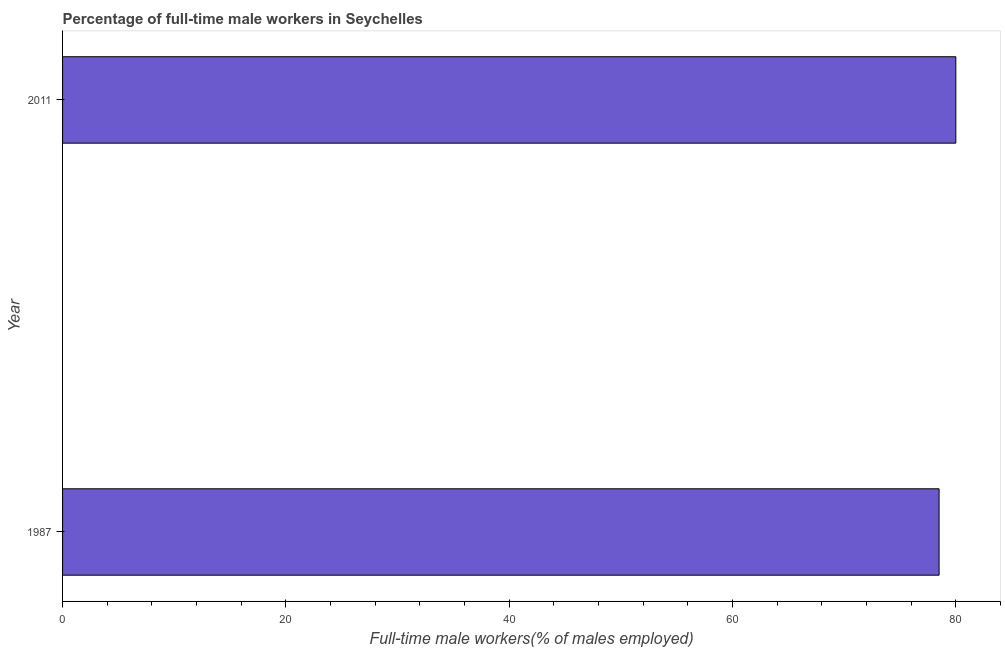Does the graph contain any zero values?
Provide a short and direct response. No. What is the title of the graph?
Ensure brevity in your answer.  Percentage of full-time male workers in Seychelles. What is the label or title of the X-axis?
Offer a very short reply. Full-time male workers(% of males employed). What is the label or title of the Y-axis?
Give a very brief answer. Year. What is the percentage of full-time male workers in 2011?
Your answer should be very brief. 80. Across all years, what is the minimum percentage of full-time male workers?
Keep it short and to the point. 78.5. In which year was the percentage of full-time male workers minimum?
Provide a succinct answer. 1987. What is the sum of the percentage of full-time male workers?
Offer a terse response. 158.5. What is the average percentage of full-time male workers per year?
Provide a short and direct response. 79.25. What is the median percentage of full-time male workers?
Make the answer very short. 79.25. Do a majority of the years between 1987 and 2011 (inclusive) have percentage of full-time male workers greater than 12 %?
Keep it short and to the point. Yes. Is the percentage of full-time male workers in 1987 less than that in 2011?
Your answer should be compact. Yes. What is the difference between two consecutive major ticks on the X-axis?
Make the answer very short. 20. Are the values on the major ticks of X-axis written in scientific E-notation?
Offer a terse response. No. What is the Full-time male workers(% of males employed) in 1987?
Your answer should be compact. 78.5. What is the Full-time male workers(% of males employed) in 2011?
Make the answer very short. 80. What is the difference between the Full-time male workers(% of males employed) in 1987 and 2011?
Make the answer very short. -1.5. 